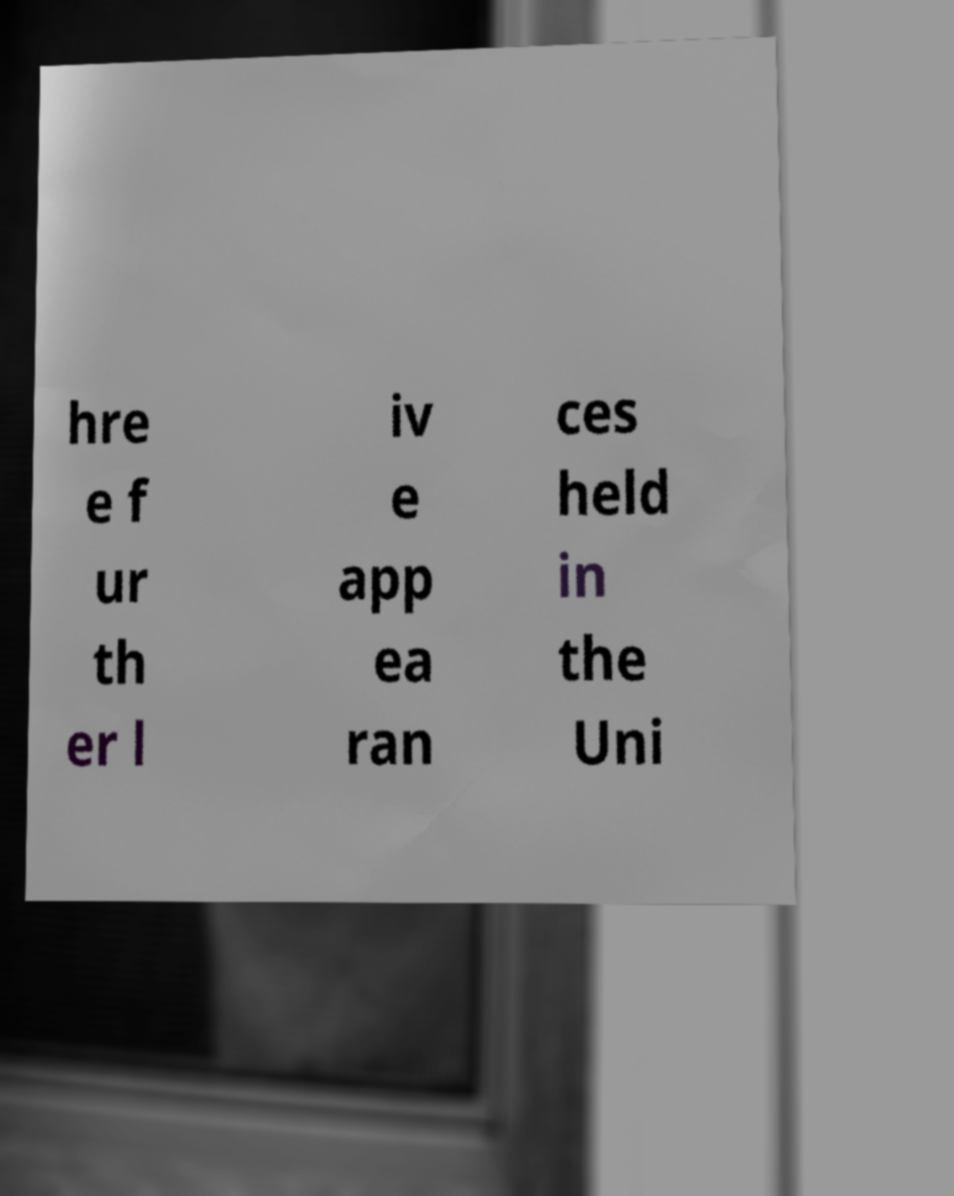Could you extract and type out the text from this image? hre e f ur th er l iv e app ea ran ces held in the Uni 